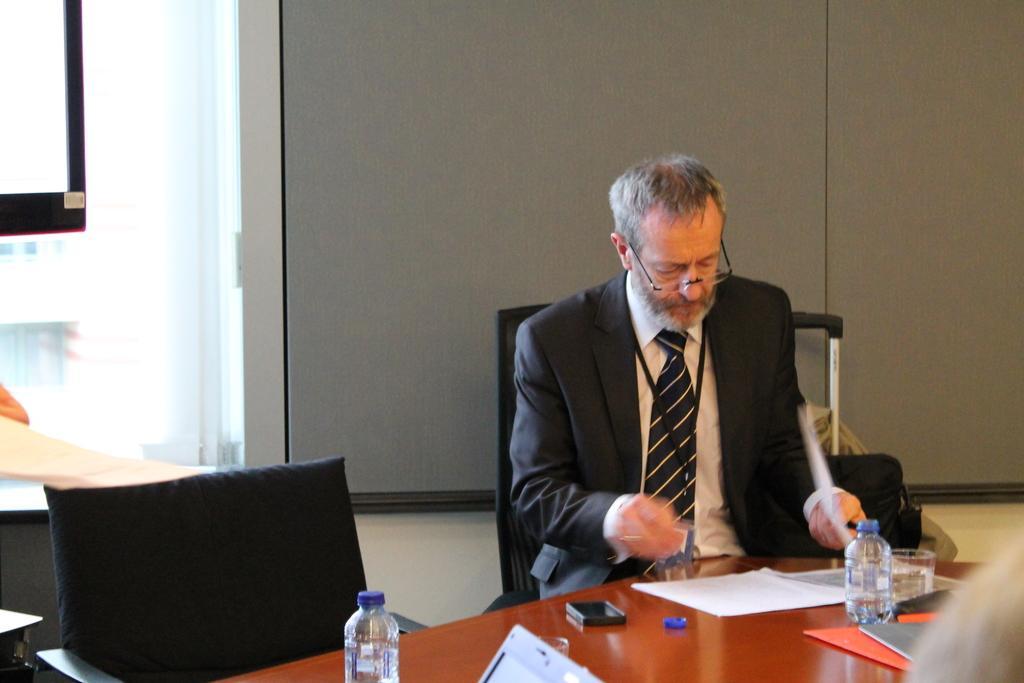In one or two sentences, can you explain what this image depicts? In this image I can see a person wearing black colored blazer, white colored shirt and black colored tie is sitting on a chair in front of a table. On the table I can see two bottles, few papers and few other objects. I can see a chair and in the background I can see the grey colored board and the white colored wall. 